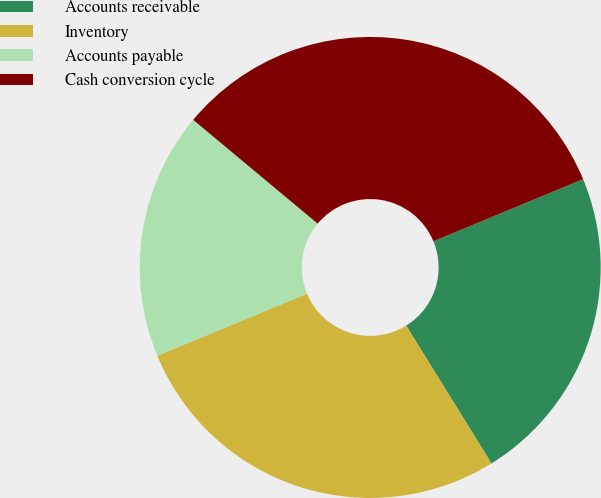Convert chart. <chart><loc_0><loc_0><loc_500><loc_500><pie_chart><fcel>Accounts receivable<fcel>Inventory<fcel>Accounts payable<fcel>Cash conversion cycle<nl><fcel>22.44%<fcel>27.56%<fcel>17.32%<fcel>32.68%<nl></chart> 